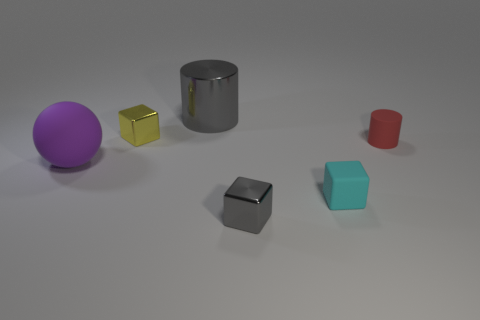Add 3 brown metal cylinders. How many objects exist? 9 Subtract all cylinders. How many objects are left? 4 Add 6 big gray things. How many big gray things are left? 7 Add 1 green rubber cylinders. How many green rubber cylinders exist? 1 Subtract 0 yellow cylinders. How many objects are left? 6 Subtract all small purple cylinders. Subtract all small red matte cylinders. How many objects are left? 5 